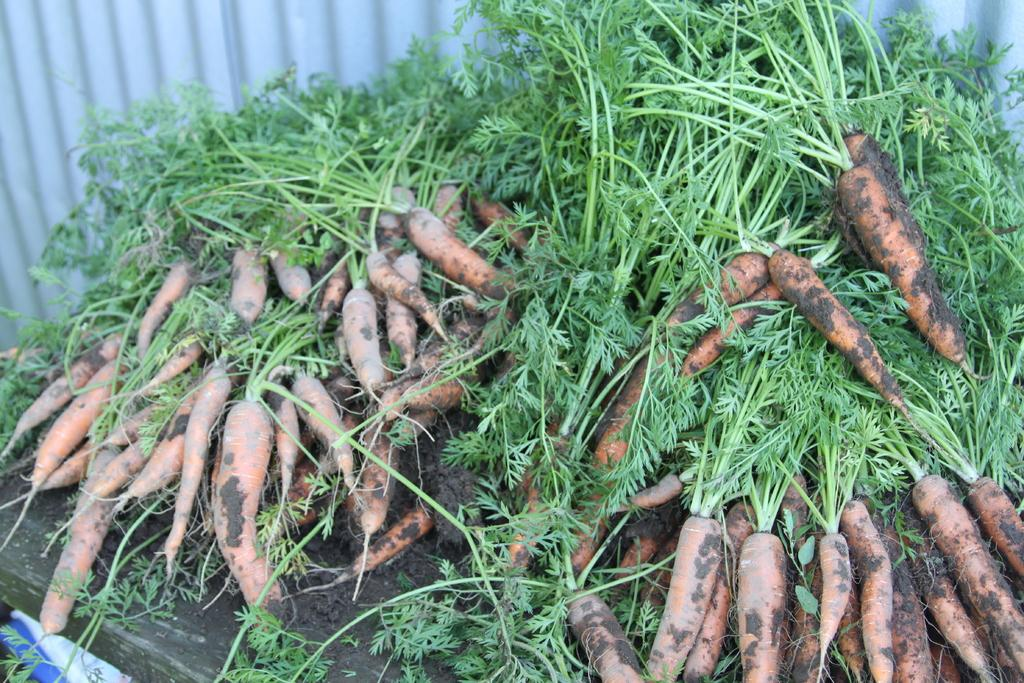What is the main subject in the center of the image? There are carrots in the center of the image. What structure can be seen at the top of the image? There is a well at the top of the image. Can you hear the cars crying in the image? There are no cars or crying sounds present in the image; it features carrots and a well. Is there a mask covering the well in the image? There is no mask present in the image; it only shows carrots and a well. 